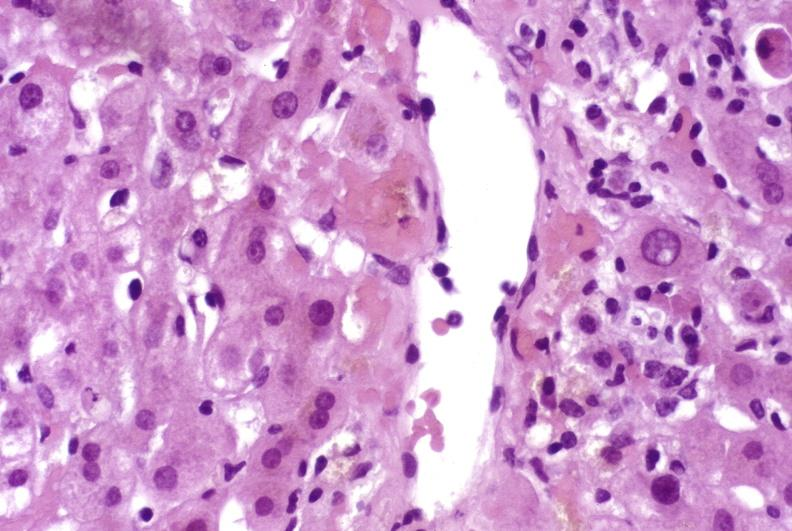what is present?
Answer the question using a single word or phrase. Liver 